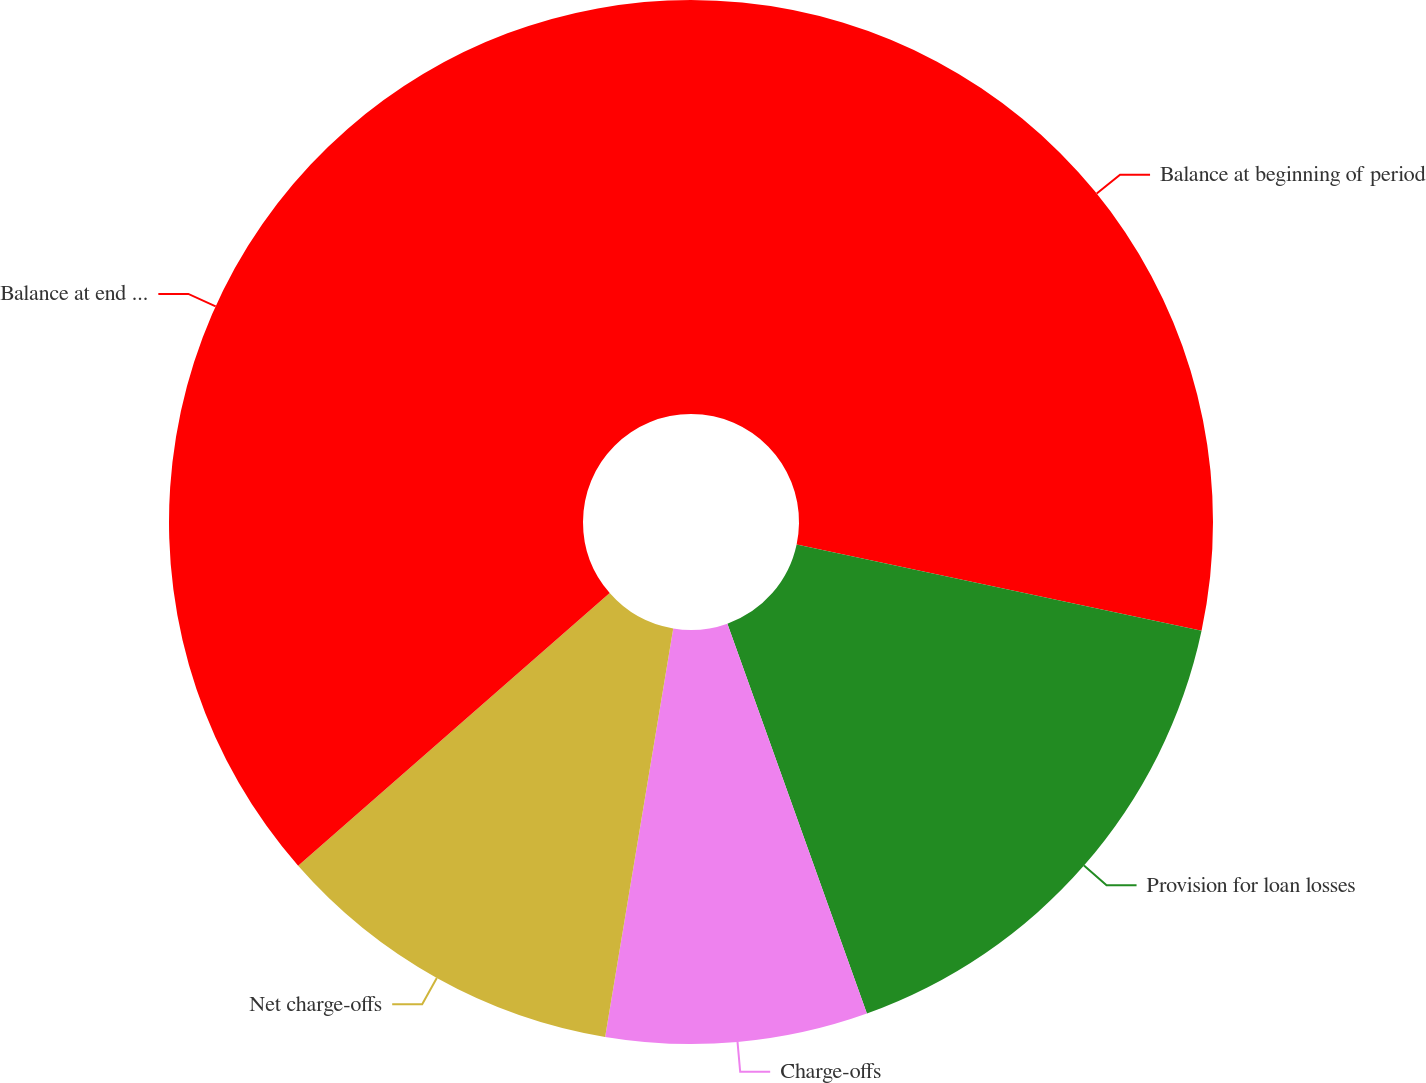Convert chart to OTSL. <chart><loc_0><loc_0><loc_500><loc_500><pie_chart><fcel>Balance at beginning of period<fcel>Provision for loan losses<fcel>Charge-offs<fcel>Net charge-offs<fcel>Balance at end of period<nl><fcel>28.34%<fcel>16.19%<fcel>8.1%<fcel>10.93%<fcel>36.44%<nl></chart> 